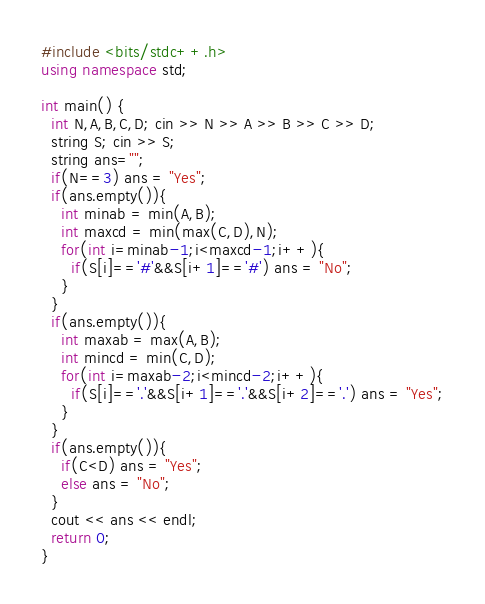Convert code to text. <code><loc_0><loc_0><loc_500><loc_500><_C++_>#include <bits/stdc++.h>
using namespace std;

int main() {
  int N,A,B,C,D; cin >> N >> A >> B >> C >> D;
  string S; cin >> S;
  string ans="";
  if(N==3) ans = "Yes";
  if(ans.empty()){
    int minab = min(A,B); 
    int maxcd = min(max(C,D),N); 
    for(int i=minab-1;i<maxcd-1;i++){
      if(S[i]=='#'&&S[i+1]=='#') ans = "No";
    }
  }
  if(ans.empty()){
    int maxab = max(A,B); 
    int mincd = min(C,D); 
    for(int i=maxab-2;i<mincd-2;i++){
      if(S[i]=='.'&&S[i+1]=='.'&&S[i+2]=='.') ans = "Yes";
    }
  }
  if(ans.empty()){
    if(C<D) ans = "Yes";
    else ans = "No";
  }
  cout << ans << endl;
  return 0;
}</code> 